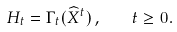<formula> <loc_0><loc_0><loc_500><loc_500>H _ { t } = \Gamma _ { t } ( \widehat { X } ^ { t } ) \, , \quad t \geq 0 .</formula> 